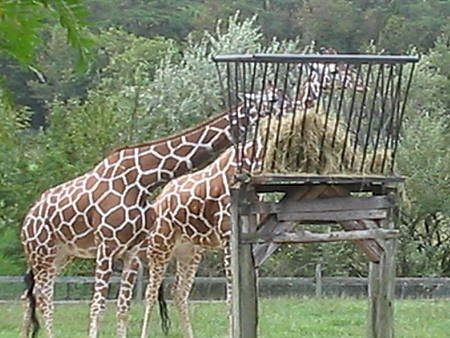Describe the objects in this image and their specific colors. I can see giraffe in darkgreen, gray, darkgray, and lightgray tones and giraffe in darkgreen, darkgray, gray, and lightgray tones in this image. 